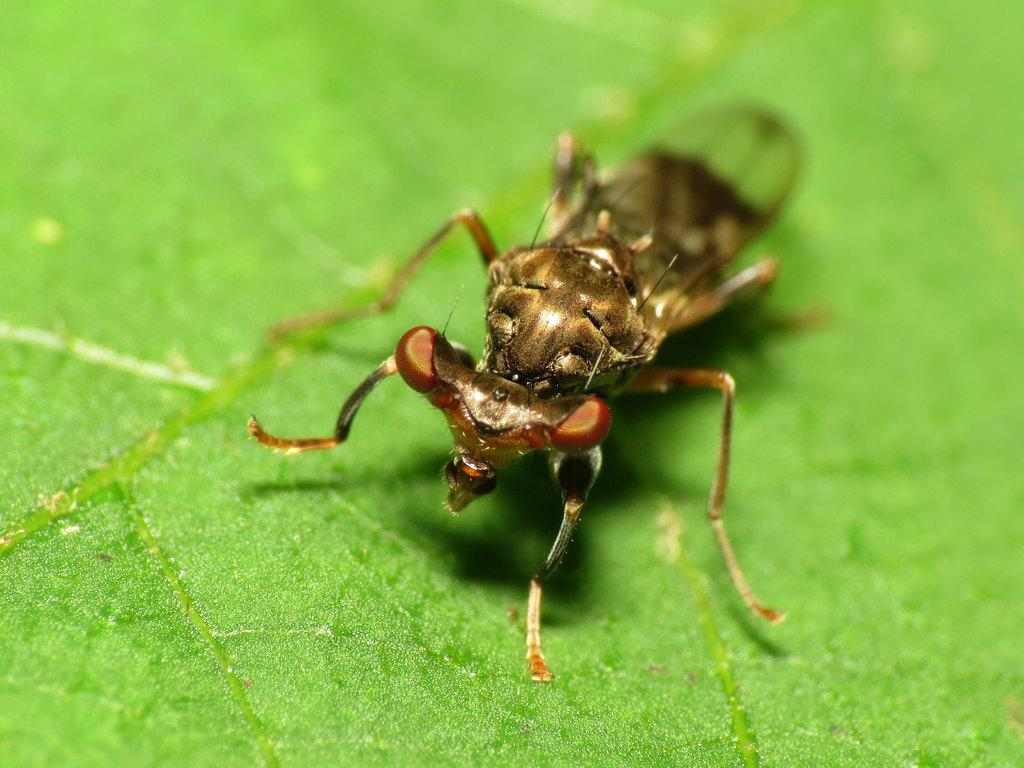What type of creature can be seen in the image? There is an insect in the image. What color is the background of the image? The background of the image is green. How is the background of the image depicted? The background of the image is blurred. What type of tray can be seen in the image? There is no tray present in the image. What type of stocking is visible on the insect in the image? Insects do not wear stockings, and there is no stocking visible on the insect in the image. 